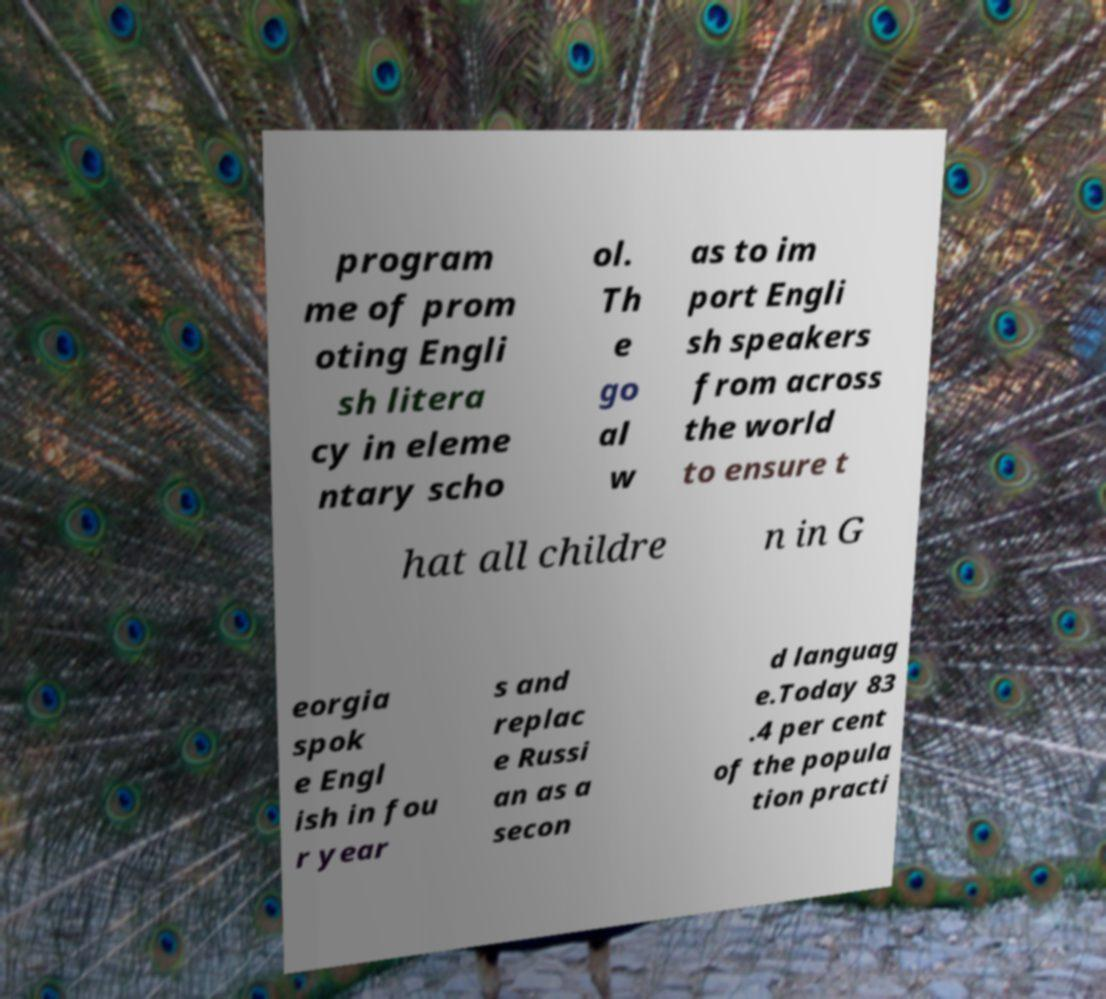For documentation purposes, I need the text within this image transcribed. Could you provide that? program me of prom oting Engli sh litera cy in eleme ntary scho ol. Th e go al w as to im port Engli sh speakers from across the world to ensure t hat all childre n in G eorgia spok e Engl ish in fou r year s and replac e Russi an as a secon d languag e.Today 83 .4 per cent of the popula tion practi 